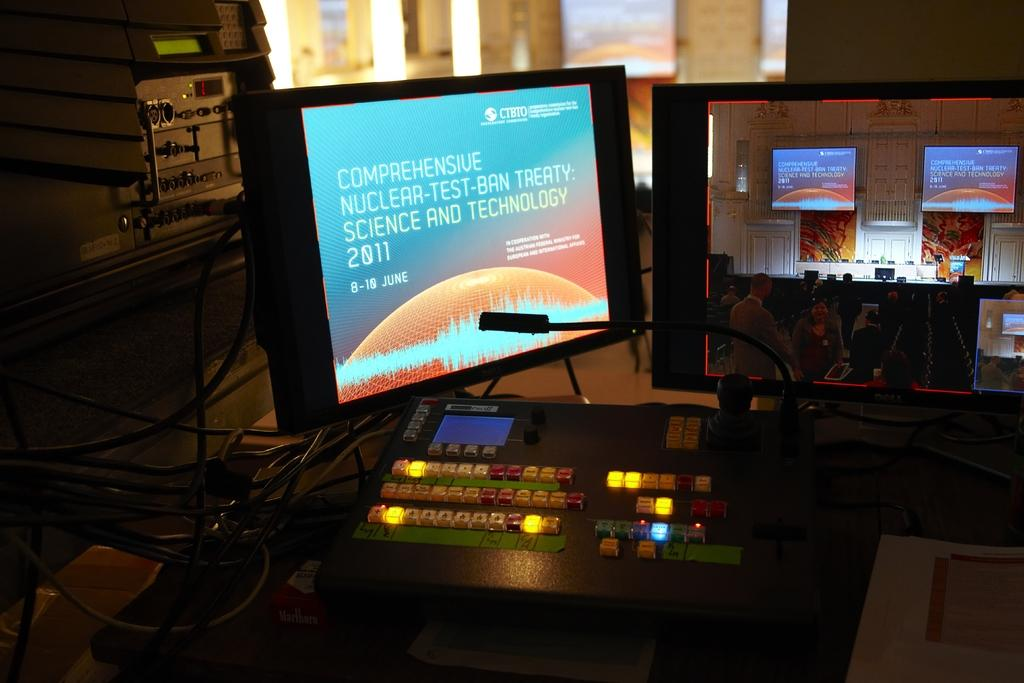<image>
Describe the image concisely. A computer displaying comprehensive nuclear-test-ban treaty science and technology 